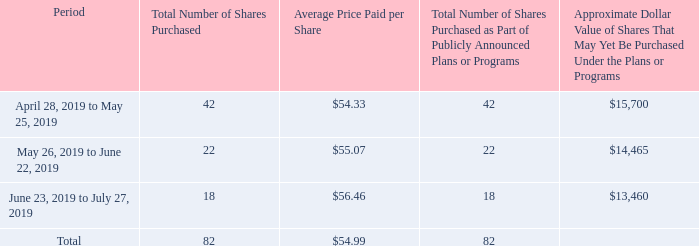Item 5. Market for Registrant’s Common Equity, Related Stockholder Matters, and Issuer Purchases of Equity Securities
(a) Cisco common stock is traded on the Nasdaq Global Select Market under the symbol CSCO. Information regarding quarterly cash dividends declared on Cisco’s common stock during fiscal 2019 and 2018 may be found in Supplementary Financial Data on page 106 of this report. There were 39,216 registered shareholders as of August 30, 2019.
(b) Not applicable.
(c) Issuer purchases of equity securities (in millions, except per-share amounts):
On September 13, 2001, we announced that our Board of Directors had authorized a stock repurchase program. On February 13, 2019, our Board of Directors authorized a $15 billion increase to the stock repurchase program. As of July 27, 2019, the remaining authorized amount for stock repurchases under this program, including the additional authorization, is approximately $13.5 billion with no termination date.
For the majority of restricted stock units granted, the number of shares issued on the date the restricted stock units vest is net of shares withheld to meet applicable tax withholding requirements. Although these withheld shares are not issued or considered common stock repurchases under our stock repurchase program and therefore are not included in the preceding table, they are treated as common stock repurchases in our financial statements as they reduce the number of shares that would have been issued upon vesting (see Note 14 to the Consolidated Financial Statements).
When did the Board of Directors authorize an increase to the stock repurchase program? On february 13, 2019, our board of directors authorized a $15 billion increase to the stock repurchase program. Where is Cisco common stock traded under? Cisco common stock is traded on the nasdaq global select market under the symbol csco. How many shareholders were there as of August 30, 2019? There were 39,216 registered shareholders as of august 30, 2019. What was the total amount paid for the shares during the period from April 28, 2019 to May 25, 2019 and May 26, 2019 to June 22, 2019?
Answer scale should be: million. (42*54.33)+(22*55.07)
Answer: 3493.4. What was the average total amount paid for the shares during the period from April 28, 2019 to May 25, 2019 and May 26, 2019 to June 22, 2019?
Answer scale should be: million. ((42*54.33)+(22*55.07))/2
Answer: 1746.7. What is the average of Average Price Paid per Share in the three period?  ($54.33+$55.07+$56.46)/3
Answer: 55.29. 